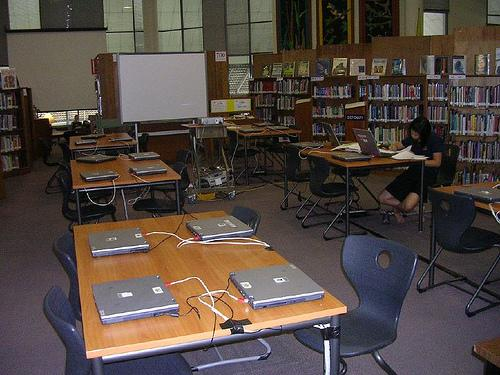Who owns those laptops?

Choices:
A) one individual
B) library
C) multiple individuals
D) non profit library 